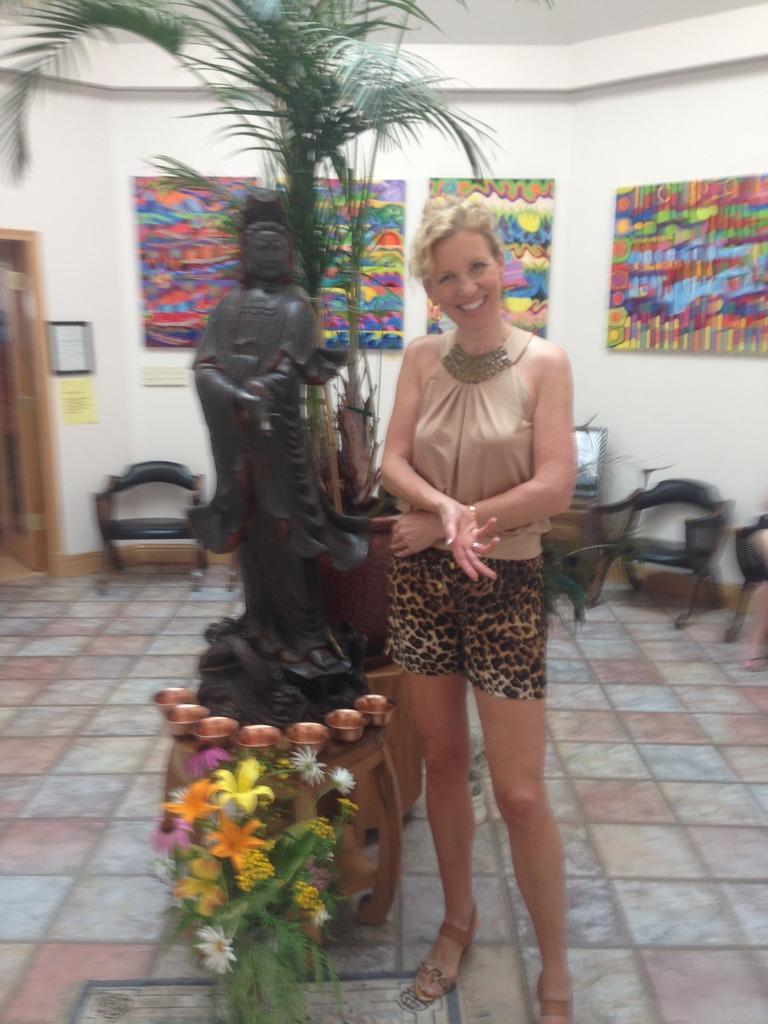How would you summarize this image in a sentence or two? This picture is taken in a room where woman is standing and having a smile on her face on the left side there is a statue behind the statue there is a plant and in front there is a flowers. In the background there are sofas and frame,paintings attached to the wall. 